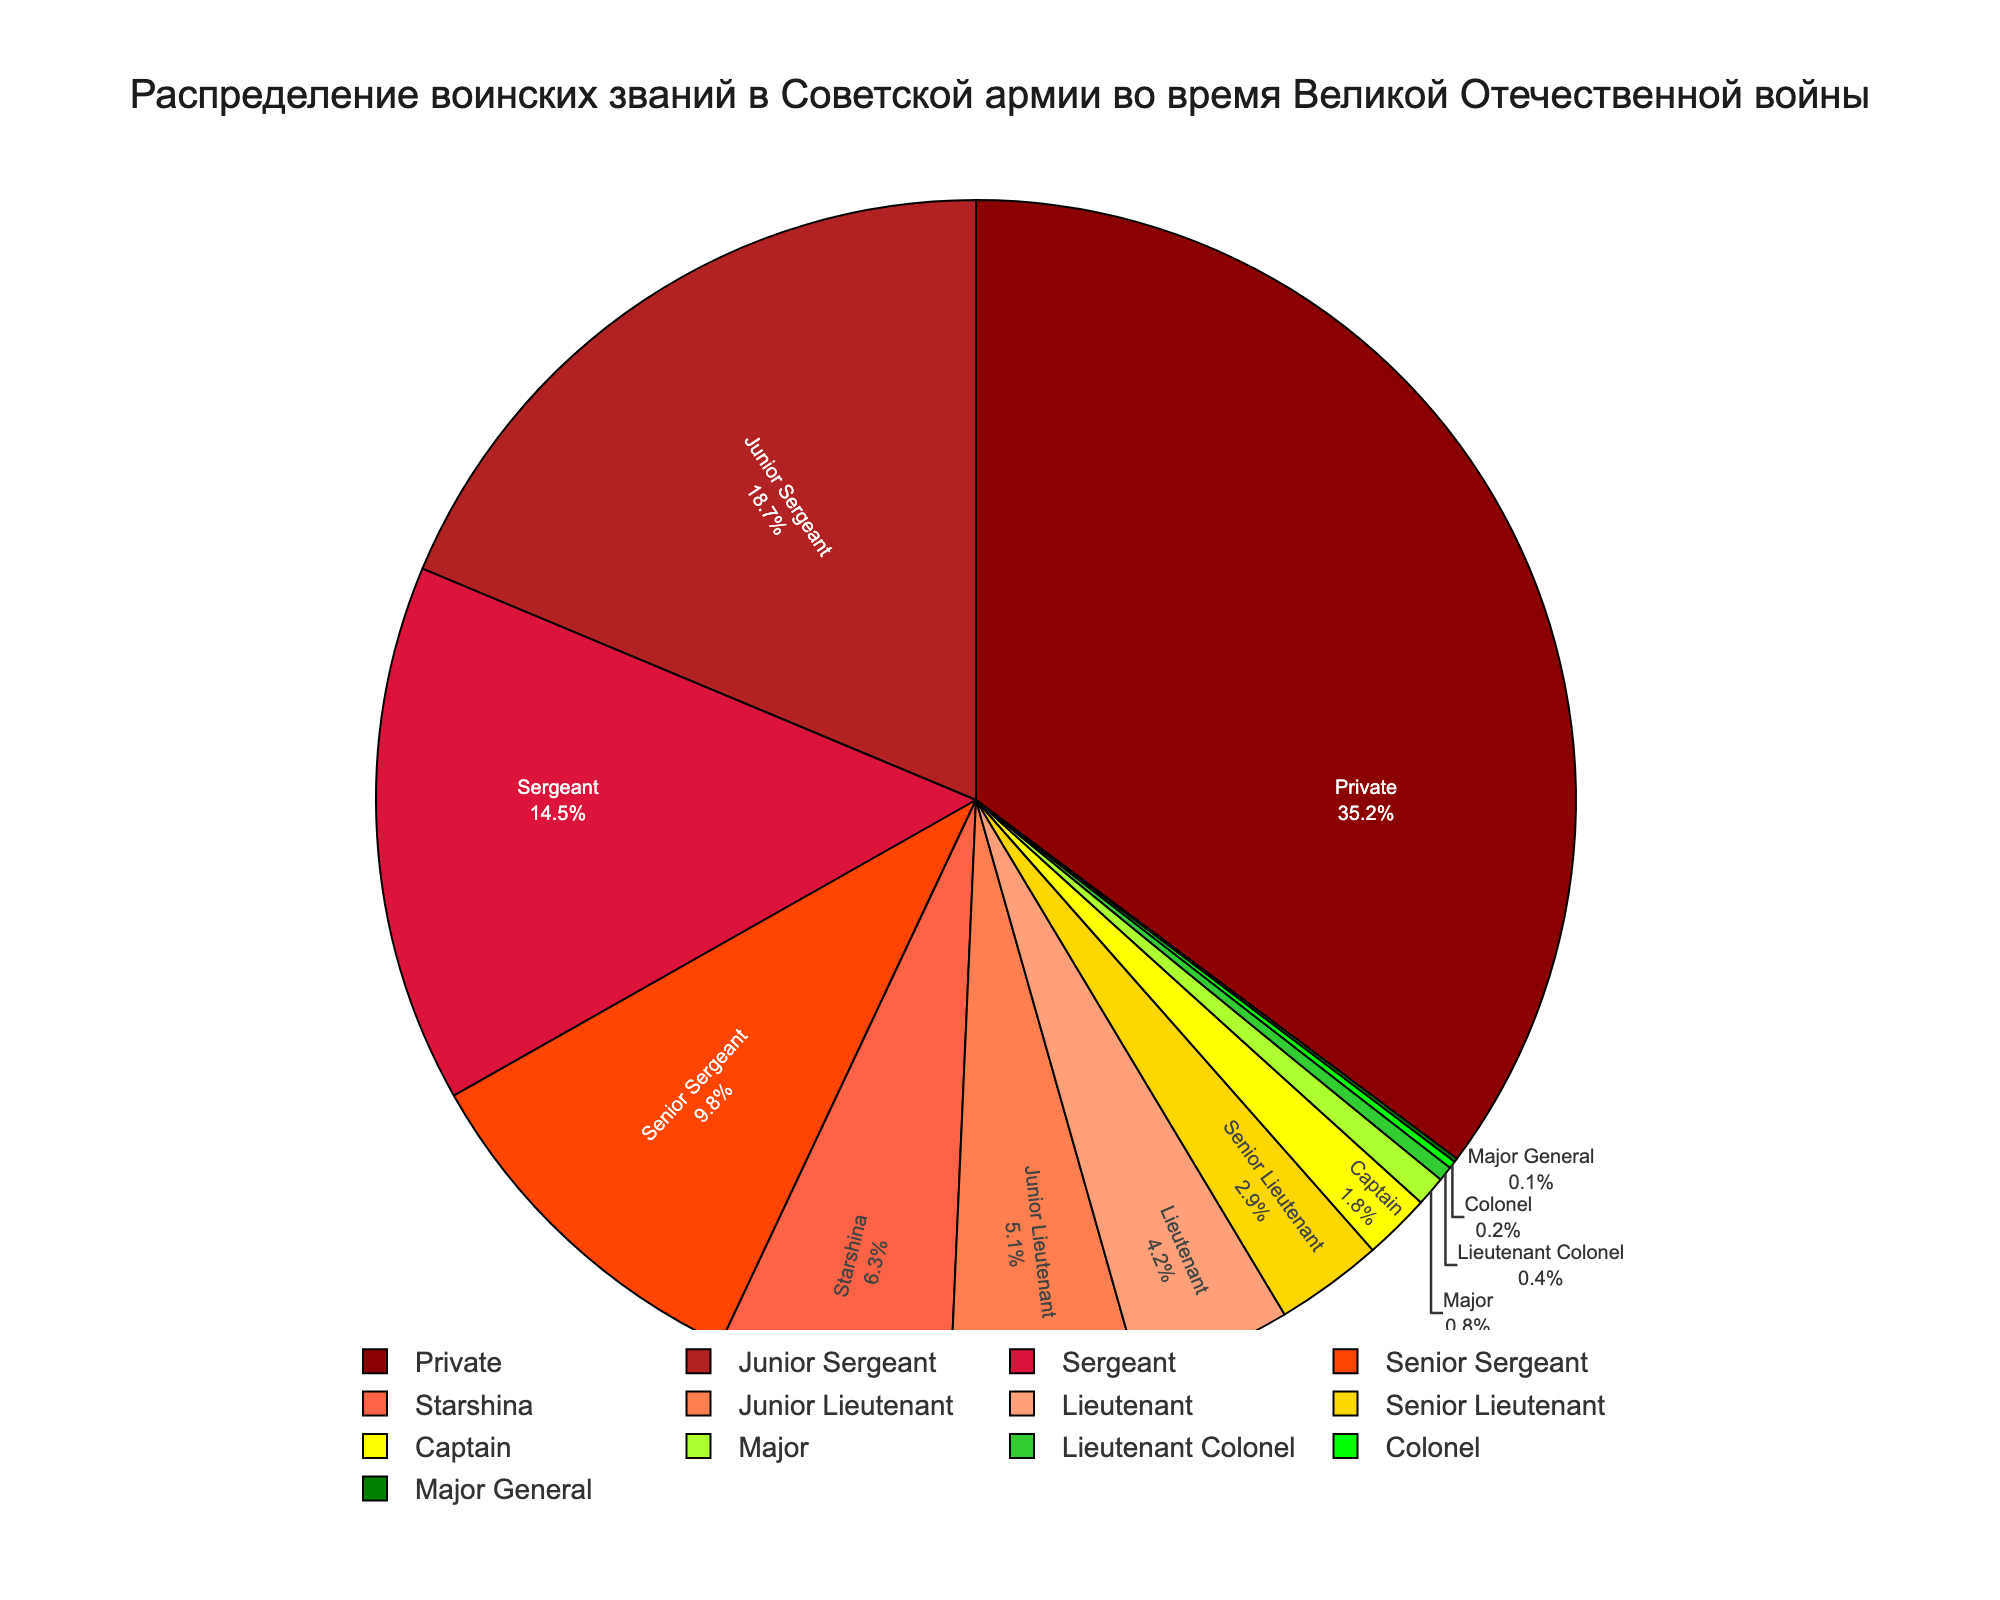What rank has the smallest percentage? The figure shows Major General with the smallest slice, which indicates it has the smallest percentage.
Answer: Major General Which two ranks have the largest combined percentage? By referring to the figure, we see the largest slices belong to Private and Junior Sergeant. Adding their percentages, 35.2% + 18.7% = 53.9%.
Answer: Private and Junior Sergeant What is the total percentage for all Sergeant ranks combined (Junior Sergeant, Sergeant, Senior Sergeant, and Starshina)? Add the percentages for Junior Sergeant (18.7%), Sergeant (14.5%), Senior Sergeant (9.8%) and Starshina (6.3%): 18.7 + 14.5 + 9.8 + 6.3 = 49.3%.
Answer: 49.3% How many ranks have percentages greater than 10%? By looking at the pie chart, we see that only Private (35.2%), Junior Sergeant (18.7%), and Sergeant (14.5%)have slices that are greater than 10%. So, there are three ranks.
Answer: 3 ranks Which rank has a percentage closest to 5%? Observe the figure and find that Junior Lieutenant has a percentage of 5.1%, which is closest to 5%.
Answer: Junior Lieutenant Which rank appears in green color, and what is its percentage? In the chart, the rank given in green is Starshina, with a percentage of 6.3%.
Answer: Starshina, 6.3% What is the difference between the percentage of Senior Lieutenant and Captain? By finding the two percentages, 2.9% for Senior Lieutenant and 1.8% for Captain, and subtracting them, we get: 2.9 - 1.8 = 1.1%.
Answer: 1.1% What percentage of the ranks are higher than Captain? The higher ranks are Major (0.8%), Lieutenant Colonel (0.4%), Colonel (0.2%), Major General (0.1%). Adding them gives us 0.8 + 0.4 + 0.2 + 0.1 = 1.5%.
Answer: 1.5% How much larger is the percentage of Privates compared to Lieutenants? Private has 35.2% and Lieutenant has 4.2%. The difference is 35.2 - 4.2 = 31%.
Answer: 31% What is the combined percentage of all Lieutenant ranks (Junior Lieutenant, Lieutenant, and Senior Lieutenant)? Find the percentages for Junior Lieutenant (5.1%), Lieutenant (4.2%), and Senior Lieutenant (2.9%), and sum them: 5.1 + 4.2 + 2.9 = 12.2%.
Answer: 12.2% 